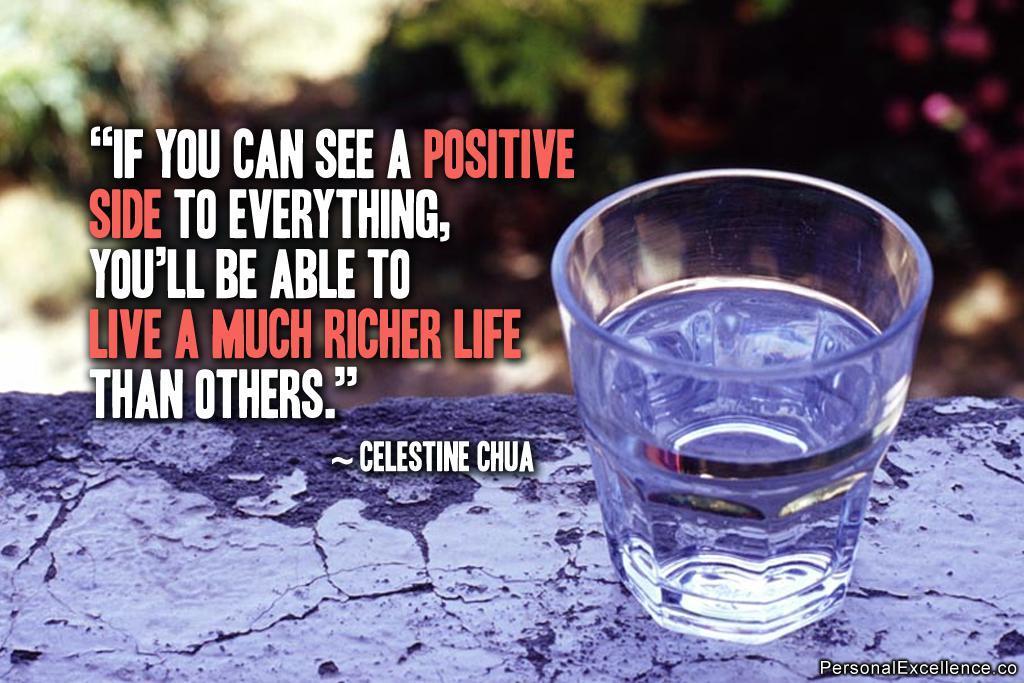Could you give a brief overview of what you see in this image? In this image I can see the floor which is black in color and on it I can see a glass with water in it. In the background I can see few trees and few flowers which are pink in color. 